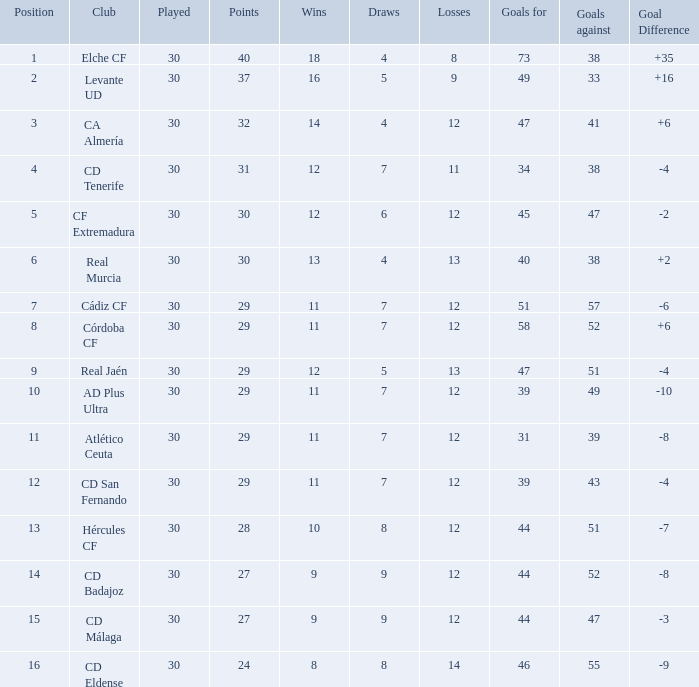What is the average number of goals against with more than 12 wins, 12 losses, and a position greater than 3? None. 